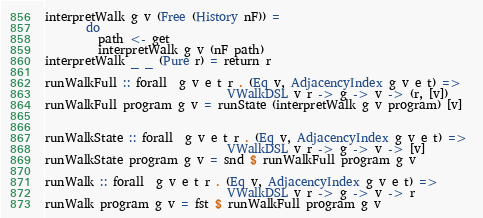Convert code to text. <code><loc_0><loc_0><loc_500><loc_500><_Haskell_>interpretWalk g v (Free (History nF)) = 
       do
         path <- get
         interpretWalk g v (nF path) 
interpretWalk _ _ (Pure r) = return r

runWalkFull :: forall  g v e t r . (Eq v, AdjacencyIndex g v e t) => 
                               VWalkDSL v r -> g -> v -> (r, [v])
runWalkFull program g v = runState (interpretWalk g v program) [v]


runWalkState :: forall  g v e t r . (Eq v, AdjacencyIndex g v e t) => 
                               VWalkDSL v r -> g -> v -> [v]
runWalkState program g v = snd $ runWalkFull program g v
  
runWalk :: forall  g v e t r . (Eq v, AdjacencyIndex g v e t) => 
                               VWalkDSL v r -> g -> v -> r
runWalk program g v = fst $ runWalkFull program g v
</code> 